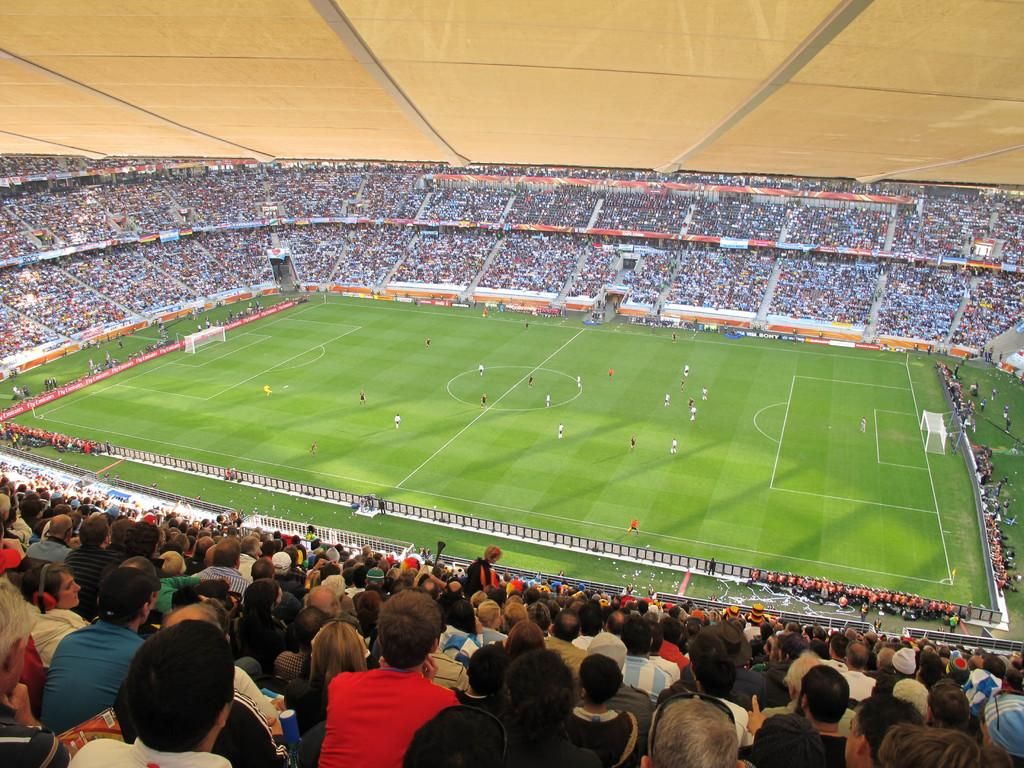What is happening in the stadium in the image? There is a crowd in the stadium, and a group of people are playing football on the ground. What time of day was the image taken? The image was taken during the day. What type of instrument is being played by the grass in the image? There is no grass playing an instrument in the image, as grass is a plant and does not have the ability to play instruments. 